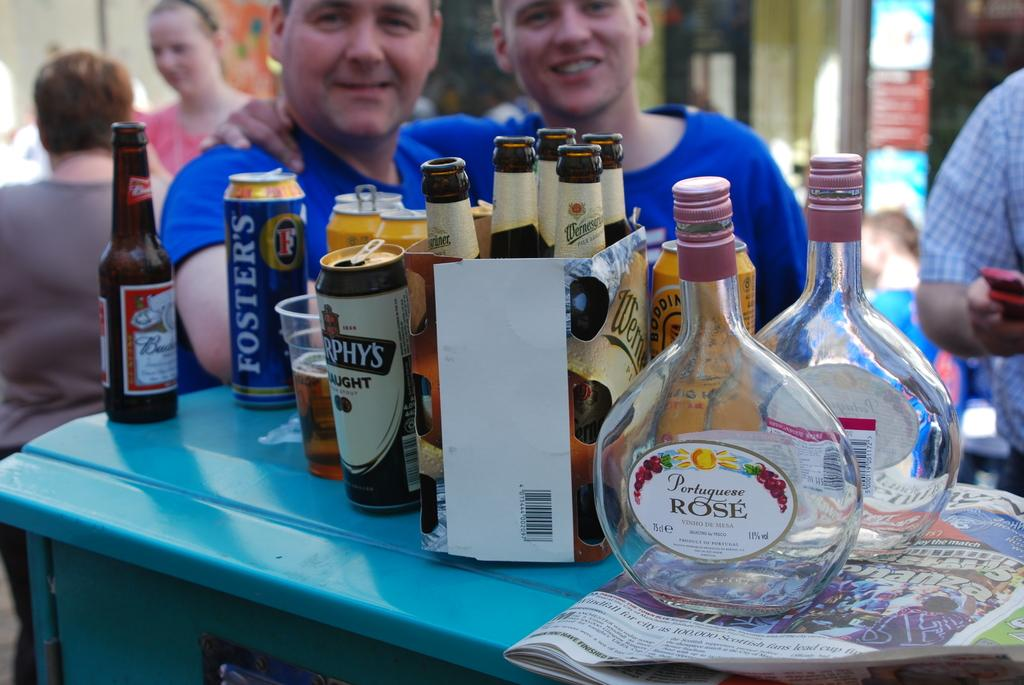<image>
Offer a succinct explanation of the picture presented. A table with multiple beer cans and bottle including Foster's beer. 